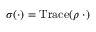<formula> <loc_0><loc_0><loc_500><loc_500>\sigma ( \cdot ) = T r a c e ( \rho \, \cdot )</formula> 